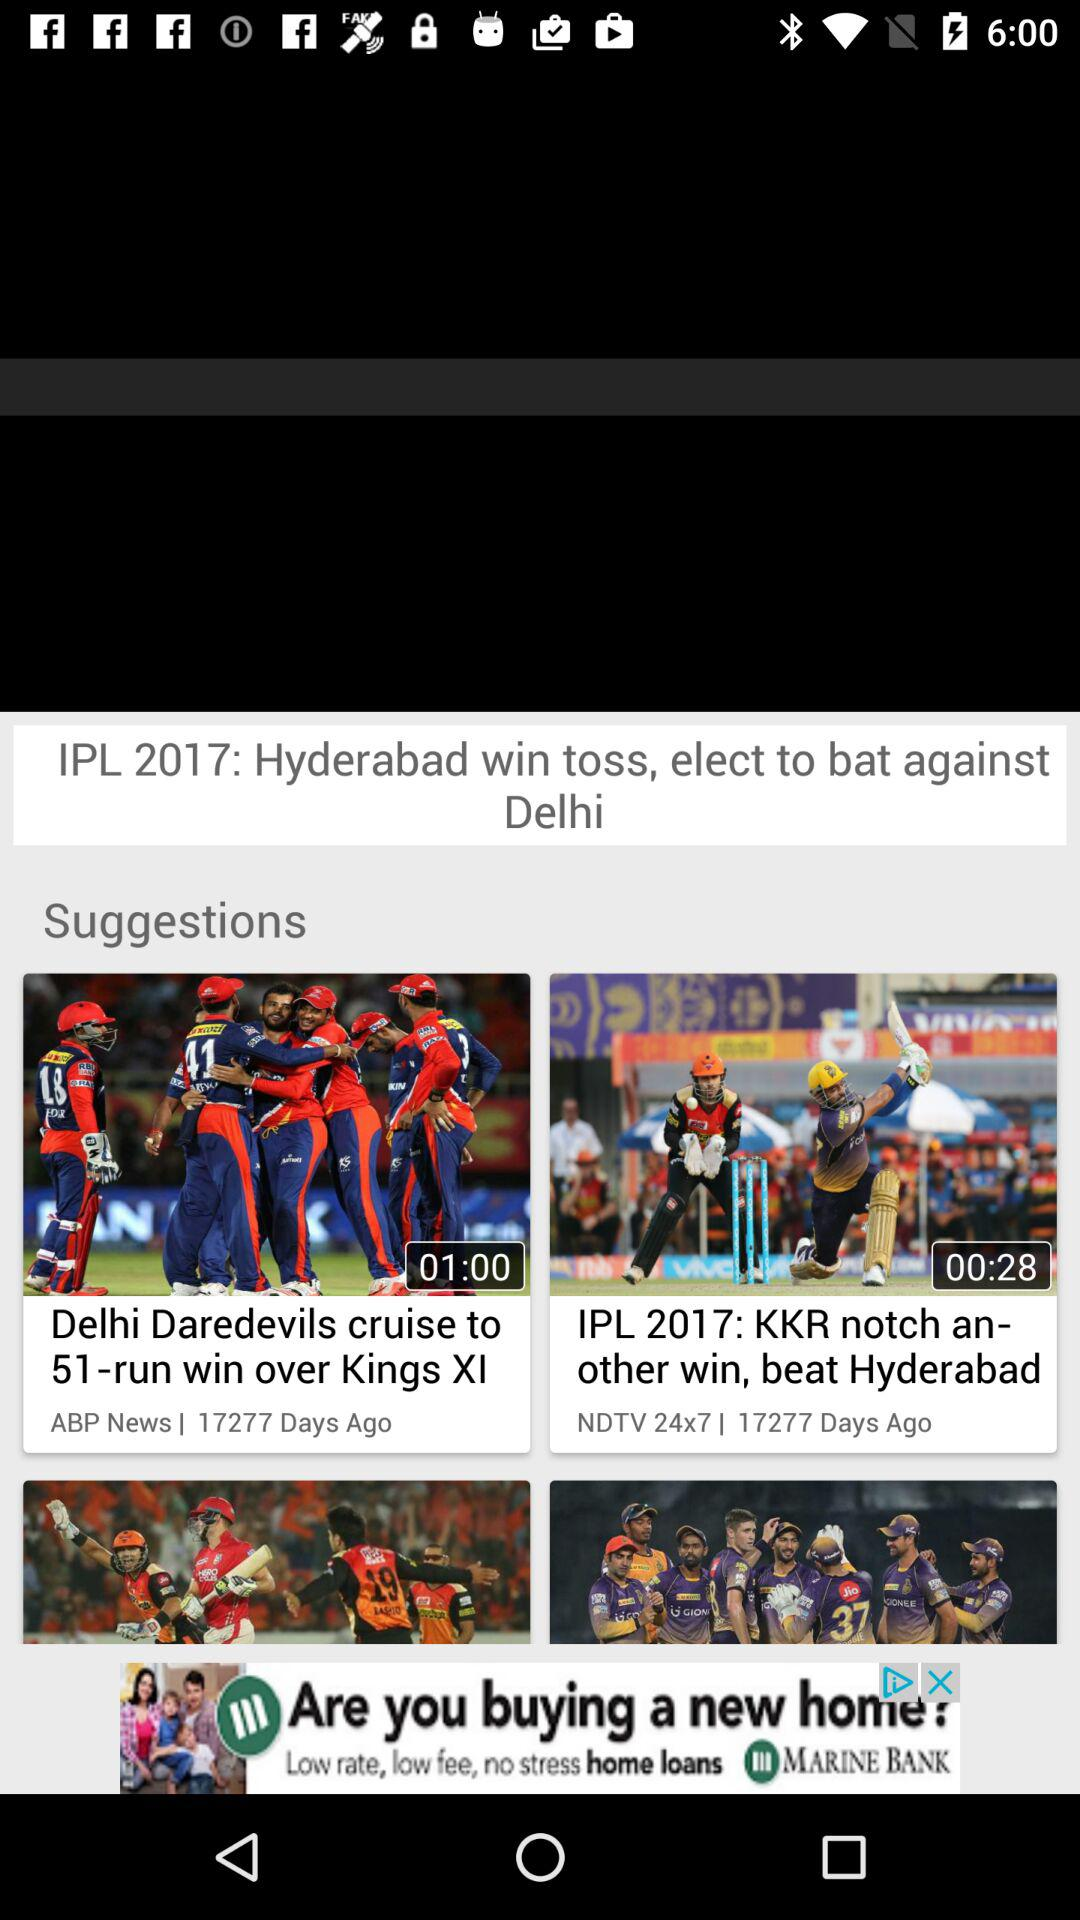What is the duration of the "Delhi Daredevils cruise to 51-run win over Kings XI" video? The duration of the video is 1 minute. 